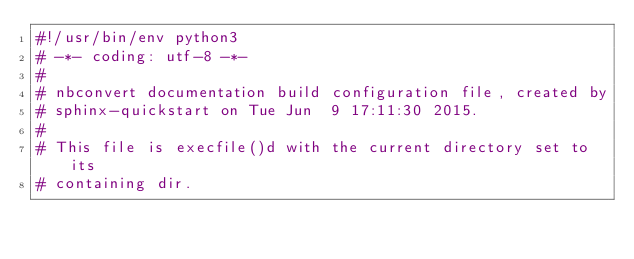<code> <loc_0><loc_0><loc_500><loc_500><_Python_>#!/usr/bin/env python3
# -*- coding: utf-8 -*-
#
# nbconvert documentation build configuration file, created by
# sphinx-quickstart on Tue Jun  9 17:11:30 2015.
#
# This file is execfile()d with the current directory set to its
# containing dir.</code> 